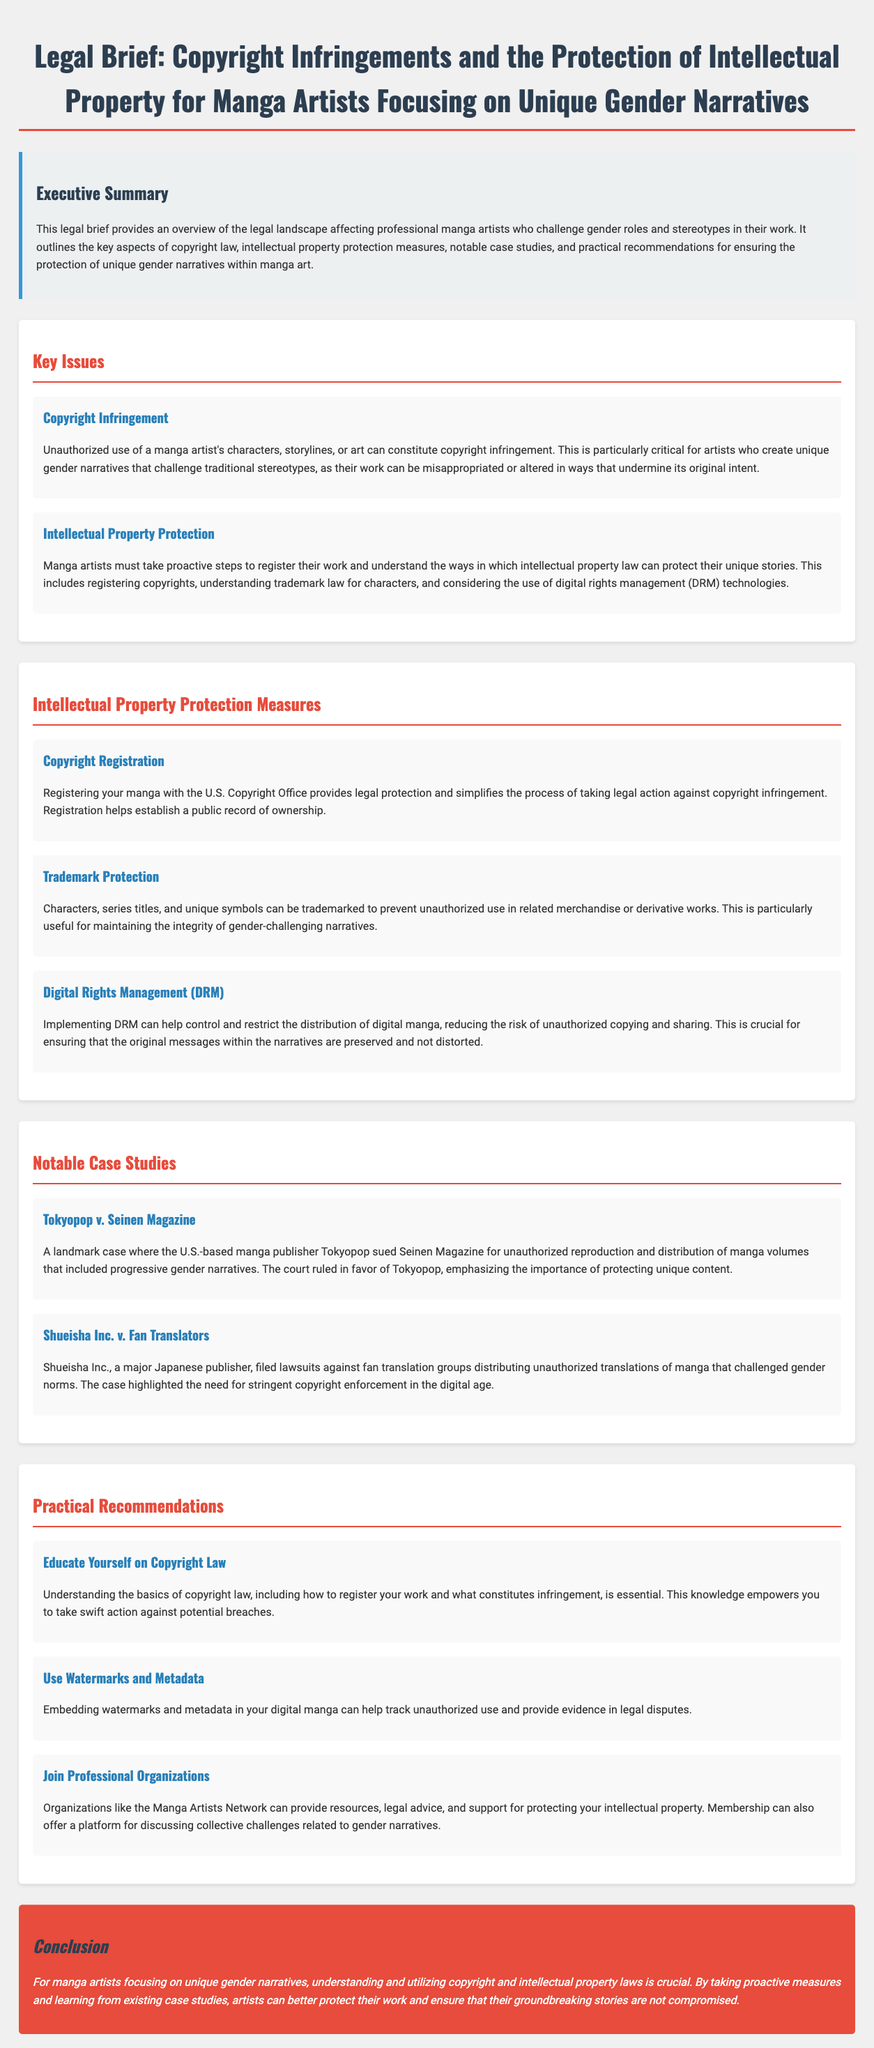what is the title of the legal brief? The title of the legal brief is mentioned at the top of the document, highlighting its focus on copyright infringements and intellectual property.
Answer: Legal Brief: Copyright Infringements and the Protection of Intellectual Property for Manga Artists Focusing on Unique Gender Narratives what is one key issue related to copyright mentioned in the document? One key issue is copyright infringement, which involves unauthorized use of a manga artist's characters, storylines, or art.
Answer: Copyright Infringement what is a recommended measure for protecting intellectual property? The document lists several measures, one of which is copyright registration to provide legal protection and simplify legal action.
Answer: Copyright Registration who is involved in the notable case study regarding unauthorized reproduction? The case study involves Tokyopop and Seinen Magazine, highlighting the issue of unauthorized reproduction of manga.
Answer: Tokyopop v. Seinen Magazine what is the purpose of Digital Rights Management (DRM) according to the document? DRM's purpose is to help control and restrict the distribution of digital manga to reduce unauthorized copying.
Answer: Control distribution what recommendation is made for artists to track unauthorized use of their work? The document suggests embedding watermarks and metadata in digital manga to help track unauthorized use.
Answer: Watermarks and Metadata what organization is mentioned as beneficial for manga artists? The document refers to the Manga Artists Network as a beneficial organization for resources and legal advice.
Answer: Manga Artists Network how does trademark protection help manga artists? Trademark protection helps prevent unauthorized use of characters, series titles, and unique symbols used in their narratives.
Answer: Prevent unauthorized use what significant case highlights the need for copyright enforcement in the digital age? The case of Shueisha Inc. v. Fan Translators illustrates the need for stringent copyright enforcement in the digital age.
Answer: Shueisha Inc. v. Fan Translators 